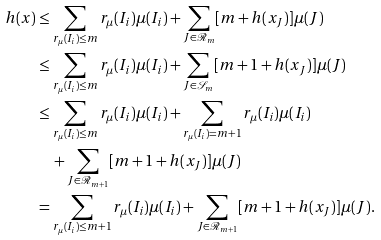Convert formula to latex. <formula><loc_0><loc_0><loc_500><loc_500>h ( x ) & \leq \sum _ { r _ { \mu } ( I _ { i } ) \leq m } r _ { \mu } ( I _ { i } ) \mu ( I _ { i } ) + \sum _ { J \in \mathcal { R } _ { m } } [ m + h ( x _ { J } ) ] \mu ( J ) \\ & \leq \sum _ { r _ { \mu } ( I _ { i } ) \leq m } r _ { \mu } ( I _ { i } ) \mu ( I _ { i } ) + \sum _ { J \in \mathcal { S } _ { m } } [ m + 1 + h ( x _ { J } ) ] \mu ( J ) \\ & \leq \sum _ { r _ { \mu } ( I _ { i } ) \leq m } r _ { \mu } ( I _ { i } ) \mu ( I _ { i } ) + \sum _ { r _ { \mu } ( I _ { i } ) = m + 1 } r _ { \mu } ( I _ { i } ) \mu ( I _ { i } ) \\ & \quad + \sum _ { J \in \mathcal { R } _ { m + 1 } } [ m + 1 + h ( x _ { J } ) ] \mu ( J ) \\ & = \sum _ { r _ { \mu } ( I _ { i } ) \leq m + 1 } r _ { \mu } ( I _ { i } ) \mu ( I _ { i } ) + \sum _ { J \in \mathcal { R } _ { m + 1 } } [ m + 1 + h ( x _ { J } ) ] \mu ( J ) .</formula> 